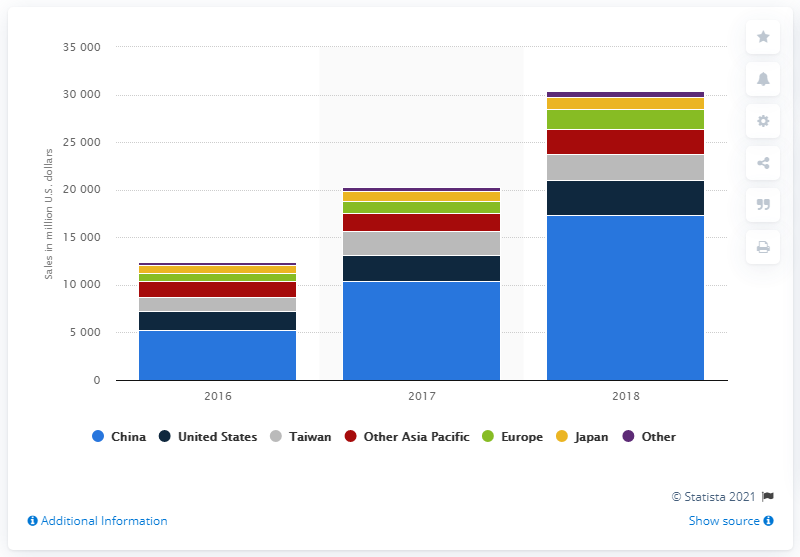Point out several critical features in this image. Micron Technology's sales in China in 2018 were approximately 17,357. 